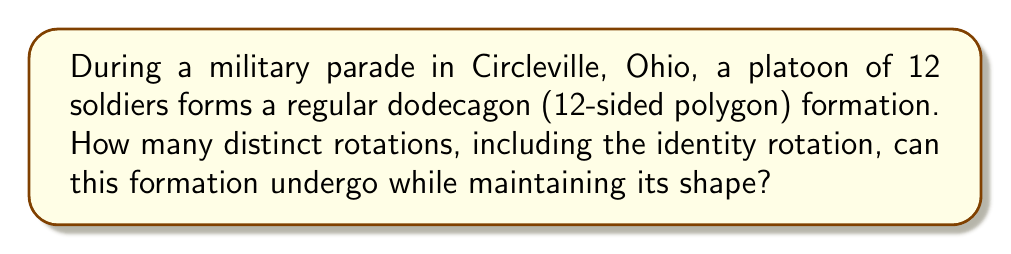Could you help me with this problem? To solve this problem, we need to consider the symmetry group of a regular dodecagon, which is directly related to the cyclic group of order 12.

1. In group theory, the rotational symmetries of a regular n-gon form a cyclic group of order n, denoted as $C_n$.

2. In this case, we have a dodecagon, so we're dealing with $C_{12}$.

3. The number of distinct rotations is equal to the order of the group $C_{12}$, which is 12.

4. These rotations can be thought of as:
   - The identity rotation (rotating by 0°)
   - Rotating by $\frac{360°}{12} = 30°$
   - Rotating by $2 \cdot 30° = 60°$
   - ...
   - Rotating by $11 \cdot 30° = 330°$

5. Mathematically, we can express these rotations as powers of a generator $r$:
   $$\{e, r, r^2, r^3, ..., r^{11}\}$$
   where $e$ is the identity element and $r$ represents a rotation by 30°.

6. Each of these rotations will result in a distinct arrangement of the soldiers in the formation, while maintaining the dodecagon shape.

Therefore, the number of distinct rotations for this military formation is 12.
Answer: 12 